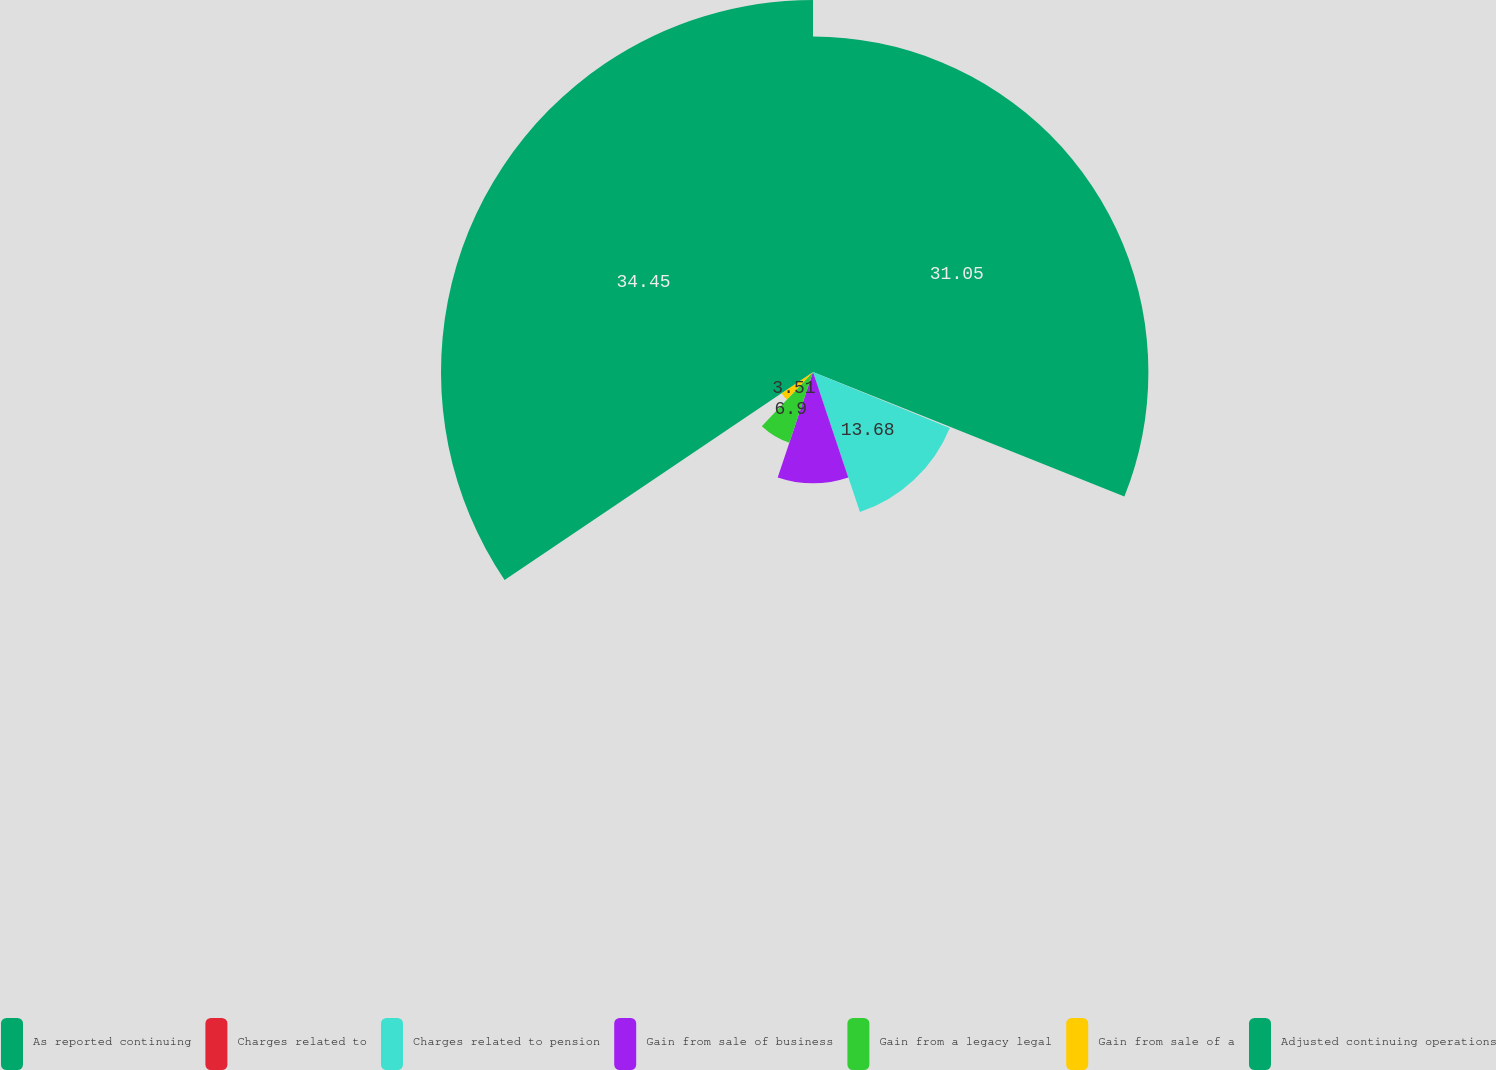<chart> <loc_0><loc_0><loc_500><loc_500><pie_chart><fcel>As reported continuing<fcel>Charges related to<fcel>Charges related to pension<fcel>Gain from sale of business<fcel>Gain from a legacy legal<fcel>Gain from sale of a<fcel>Adjusted continuing operations<nl><fcel>31.05%<fcel>0.12%<fcel>13.68%<fcel>10.29%<fcel>6.9%<fcel>3.51%<fcel>34.44%<nl></chart> 